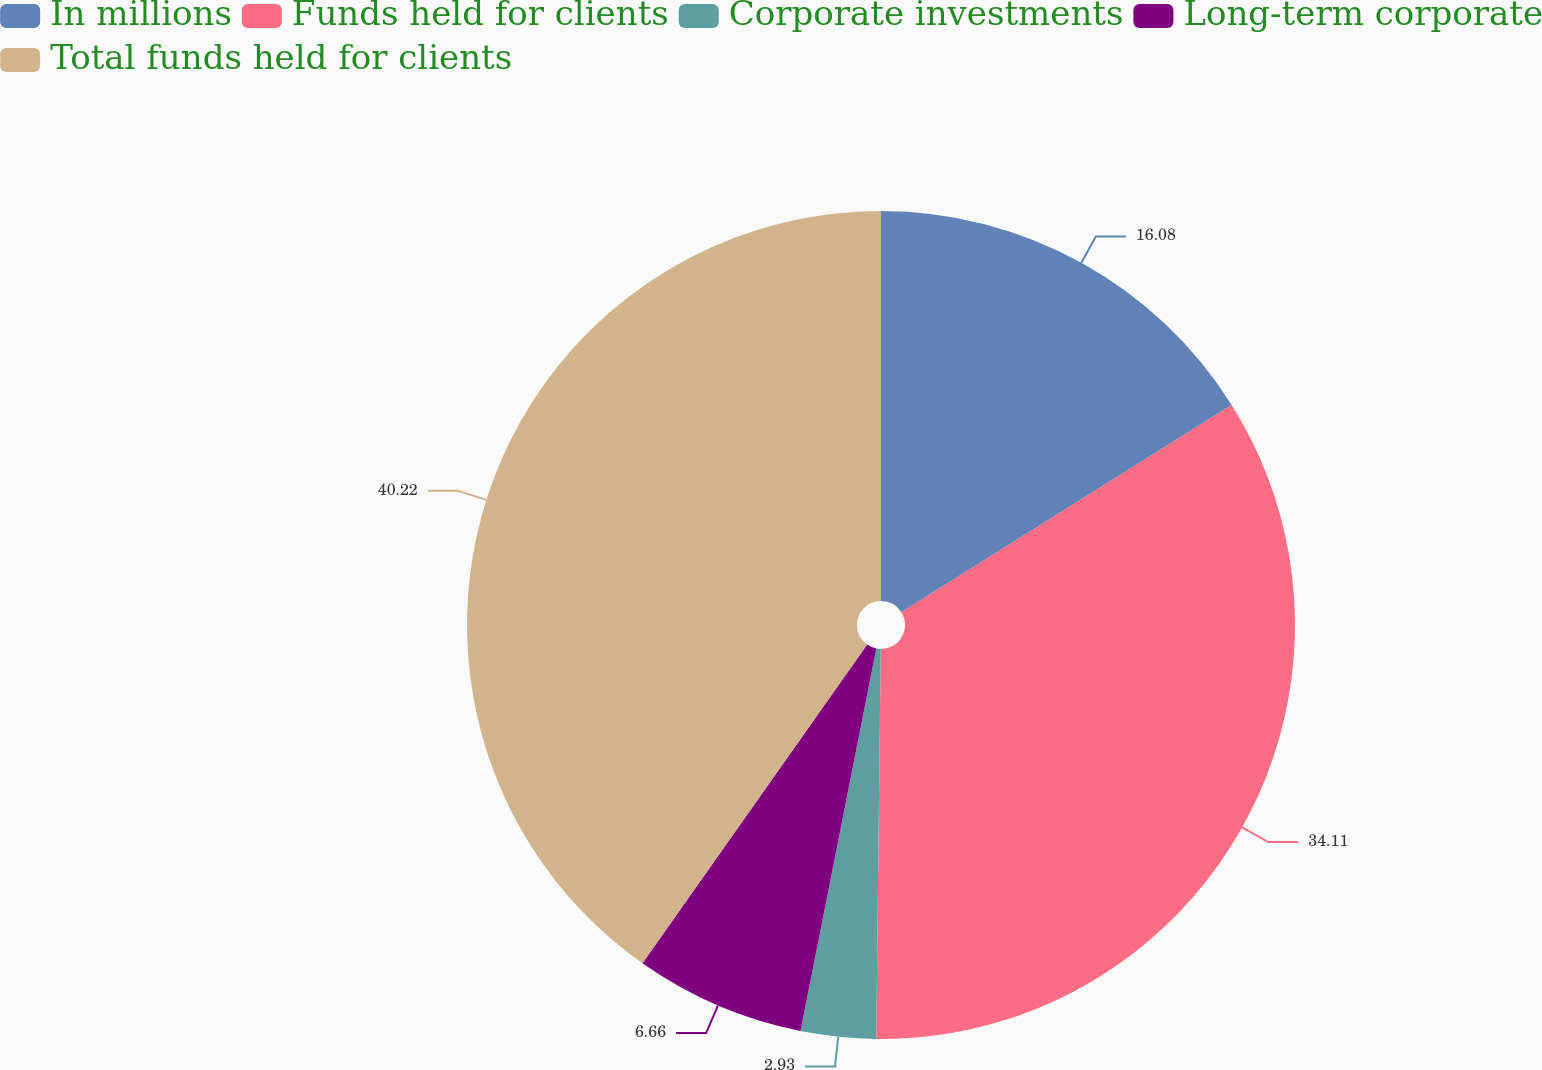<chart> <loc_0><loc_0><loc_500><loc_500><pie_chart><fcel>In millions<fcel>Funds held for clients<fcel>Corporate investments<fcel>Long-term corporate<fcel>Total funds held for clients<nl><fcel>16.08%<fcel>34.11%<fcel>2.93%<fcel>6.66%<fcel>40.23%<nl></chart> 